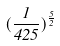Convert formula to latex. <formula><loc_0><loc_0><loc_500><loc_500>( \frac { 1 } { 4 2 5 } ) ^ { \frac { 5 } { 2 } }</formula> 